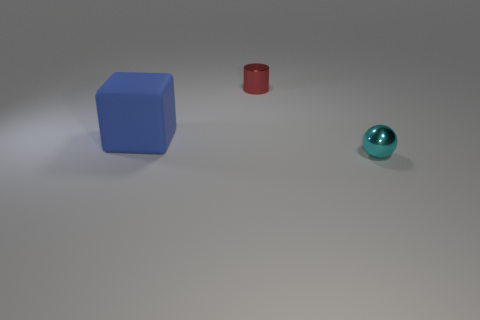What number of tiny objects are cyan shiny objects or red shiny cylinders?
Provide a succinct answer. 2. There is a thing that is on the left side of the tiny metallic cylinder; what is its shape?
Your response must be concise. Cube. How many small cylinders are there?
Ensure brevity in your answer.  1. Do the big cube and the red object have the same material?
Offer a very short reply. No. Are there more large blue blocks that are right of the metal cylinder than balls?
Make the answer very short. No. What number of objects are either red cylinders or tiny objects behind the block?
Provide a short and direct response. 1. Is the number of red metal things in front of the large object greater than the number of red things behind the tiny red thing?
Offer a very short reply. No. There is a thing left of the tiny object left of the shiny thing in front of the blue object; what is it made of?
Offer a terse response. Rubber. The cyan object that is made of the same material as the small red cylinder is what shape?
Provide a succinct answer. Sphere. Is there a cylinder in front of the cube that is to the left of the cylinder?
Your response must be concise. No. 